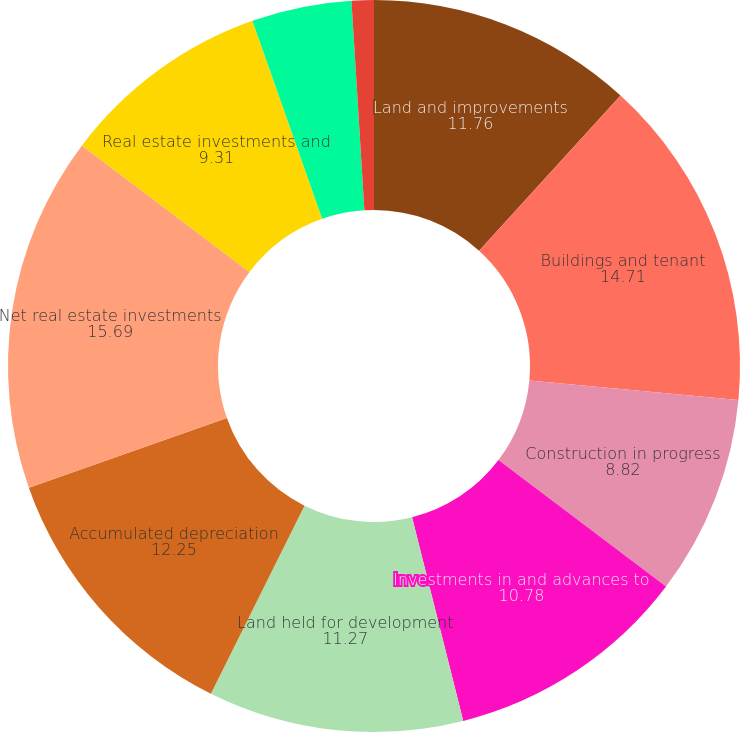Convert chart to OTSL. <chart><loc_0><loc_0><loc_500><loc_500><pie_chart><fcel>Land and improvements<fcel>Buildings and tenant<fcel>Construction in progress<fcel>Investments in and advances to<fcel>Land held for development<fcel>Accumulated depreciation<fcel>Net real estate investments<fcel>Real estate investments and<fcel>Cash and cash equivalents<fcel>Accounts receivable net of<nl><fcel>11.76%<fcel>14.71%<fcel>8.82%<fcel>10.78%<fcel>11.27%<fcel>12.25%<fcel>15.69%<fcel>9.31%<fcel>4.41%<fcel>0.98%<nl></chart> 